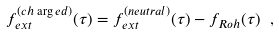Convert formula to latex. <formula><loc_0><loc_0><loc_500><loc_500>f ^ { ( c h \arg e d ) } _ { e x t } ( \tau ) = f ^ { ( n e u t r a l ) } _ { e x t } ( \tau ) - f _ { R o h } ( \tau ) \ ,</formula> 